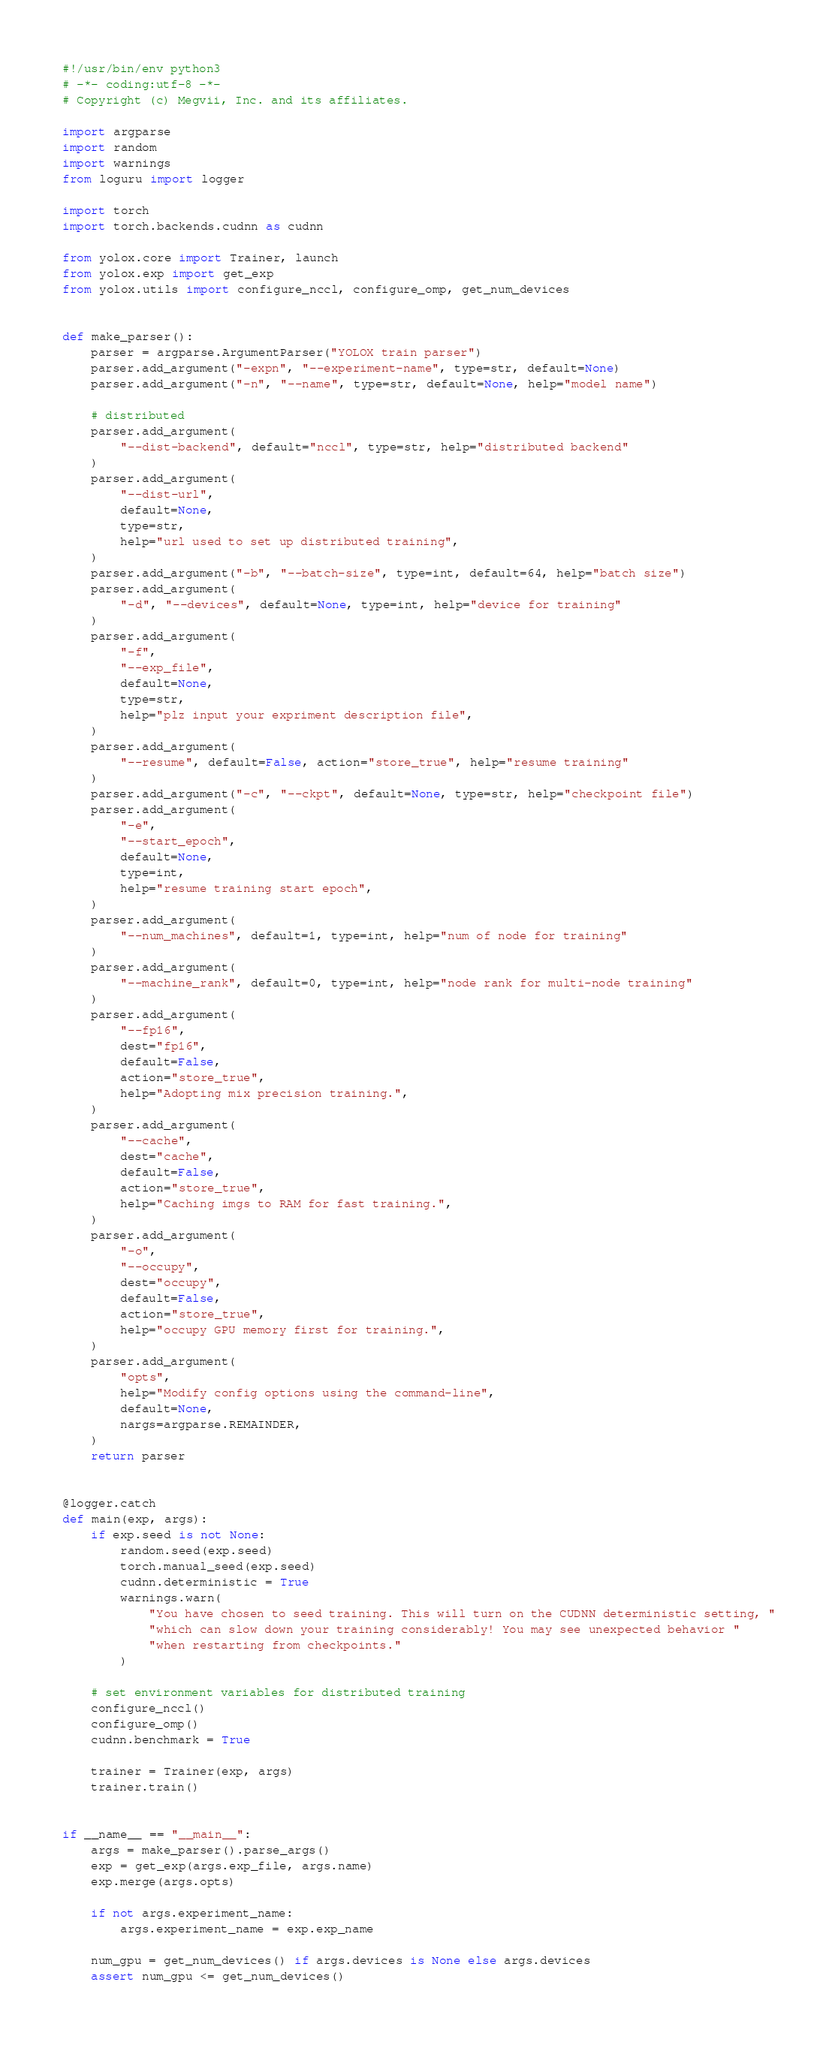Convert code to text. <code><loc_0><loc_0><loc_500><loc_500><_Python_>#!/usr/bin/env python3
# -*- coding:utf-8 -*-
# Copyright (c) Megvii, Inc. and its affiliates.

import argparse
import random
import warnings
from loguru import logger

import torch
import torch.backends.cudnn as cudnn

from yolox.core import Trainer, launch
from yolox.exp import get_exp
from yolox.utils import configure_nccl, configure_omp, get_num_devices


def make_parser():
    parser = argparse.ArgumentParser("YOLOX train parser")
    parser.add_argument("-expn", "--experiment-name", type=str, default=None)
    parser.add_argument("-n", "--name", type=str, default=None, help="model name")

    # distributed
    parser.add_argument(
        "--dist-backend", default="nccl", type=str, help="distributed backend"
    )
    parser.add_argument(
        "--dist-url",
        default=None,
        type=str,
        help="url used to set up distributed training",
    )
    parser.add_argument("-b", "--batch-size", type=int, default=64, help="batch size")
    parser.add_argument(
        "-d", "--devices", default=None, type=int, help="device for training"
    )
    parser.add_argument(
        "-f",
        "--exp_file",
        default=None,
        type=str,
        help="plz input your expriment description file",
    )
    parser.add_argument(
        "--resume", default=False, action="store_true", help="resume training"
    )
    parser.add_argument("-c", "--ckpt", default=None, type=str, help="checkpoint file")
    parser.add_argument(
        "-e",
        "--start_epoch",
        default=None,
        type=int,
        help="resume training start epoch",
    )
    parser.add_argument(
        "--num_machines", default=1, type=int, help="num of node for training"
    )
    parser.add_argument(
        "--machine_rank", default=0, type=int, help="node rank for multi-node training"
    )
    parser.add_argument(
        "--fp16",
        dest="fp16",
        default=False,
        action="store_true",
        help="Adopting mix precision training.",
    )
    parser.add_argument(
        "--cache",
        dest="cache",
        default=False,
        action="store_true",
        help="Caching imgs to RAM for fast training.",
    )
    parser.add_argument(
        "-o",
        "--occupy",
        dest="occupy",
        default=False,
        action="store_true",
        help="occupy GPU memory first for training.",
    )
    parser.add_argument(
        "opts",
        help="Modify config options using the command-line",
        default=None,
        nargs=argparse.REMAINDER,
    )
    return parser


@logger.catch
def main(exp, args):
    if exp.seed is not None:
        random.seed(exp.seed)
        torch.manual_seed(exp.seed)
        cudnn.deterministic = True
        warnings.warn(
            "You have chosen to seed training. This will turn on the CUDNN deterministic setting, "
            "which can slow down your training considerably! You may see unexpected behavior "
            "when restarting from checkpoints."
        )

    # set environment variables for distributed training
    configure_nccl()
    configure_omp()
    cudnn.benchmark = True

    trainer = Trainer(exp, args)
    trainer.train()


if __name__ == "__main__":
    args = make_parser().parse_args()
    exp = get_exp(args.exp_file, args.name)
    exp.merge(args.opts)

    if not args.experiment_name:
        args.experiment_name = exp.exp_name

    num_gpu = get_num_devices() if args.devices is None else args.devices
    assert num_gpu <= get_num_devices()
</code> 